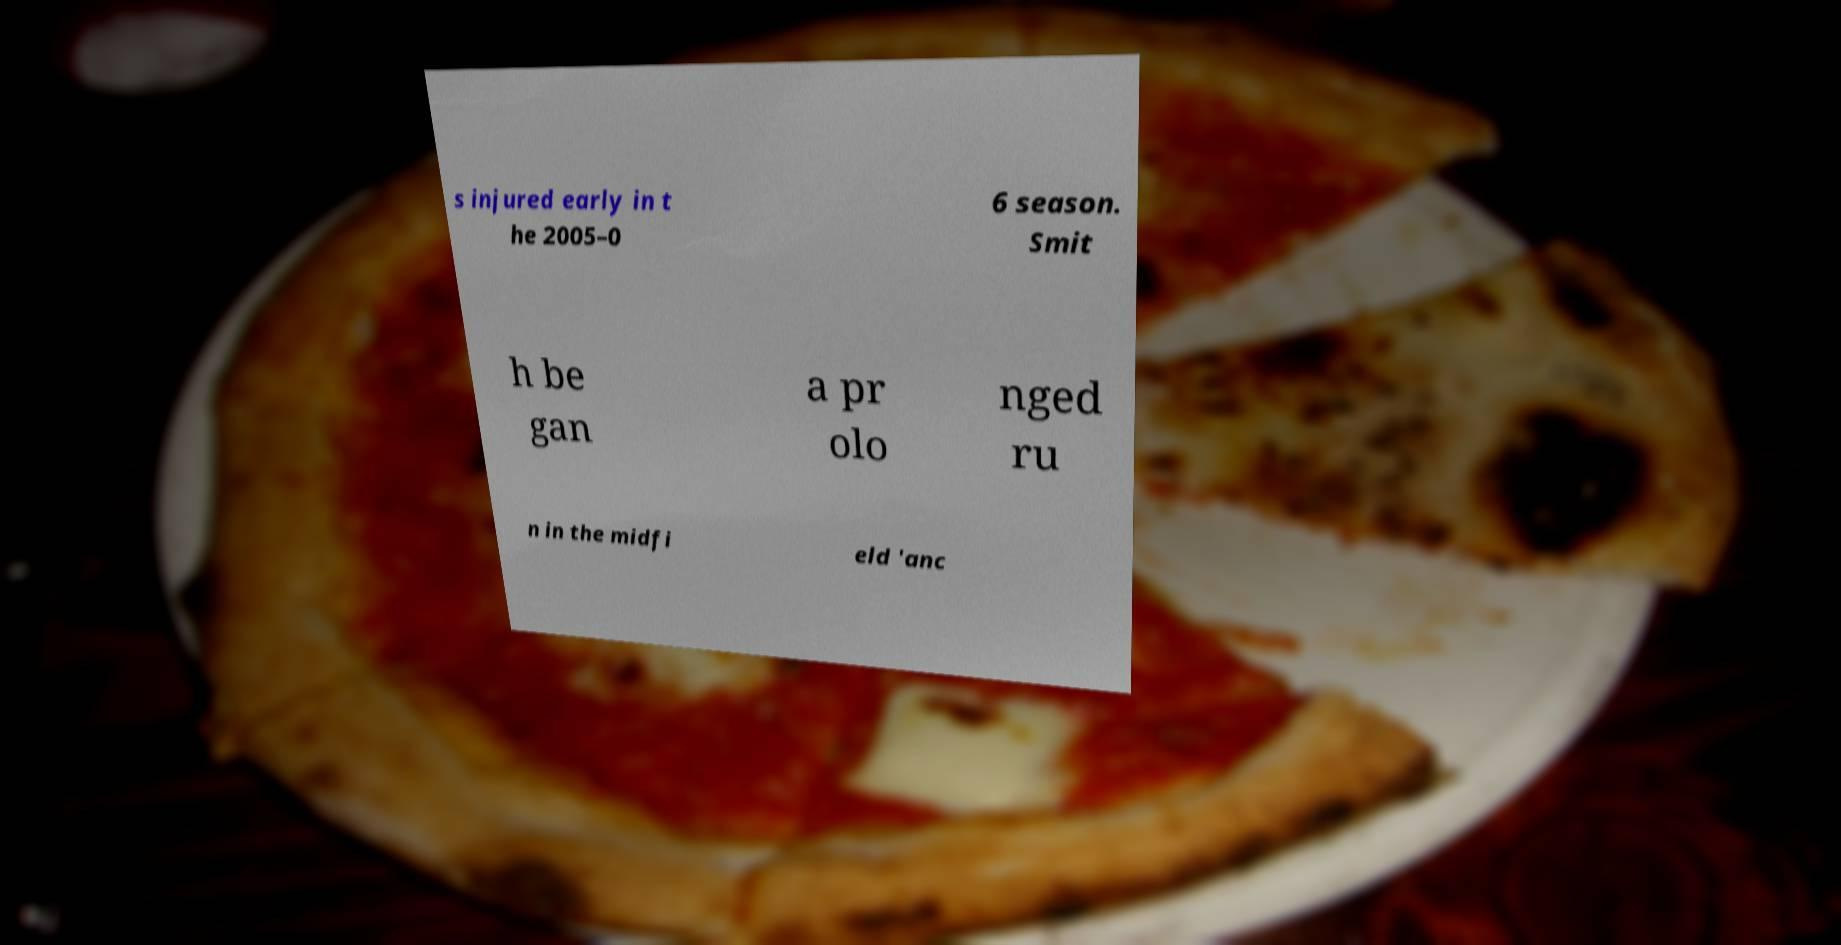I need the written content from this picture converted into text. Can you do that? s injured early in t he 2005–0 6 season. Smit h be gan a pr olo nged ru n in the midfi eld 'anc 